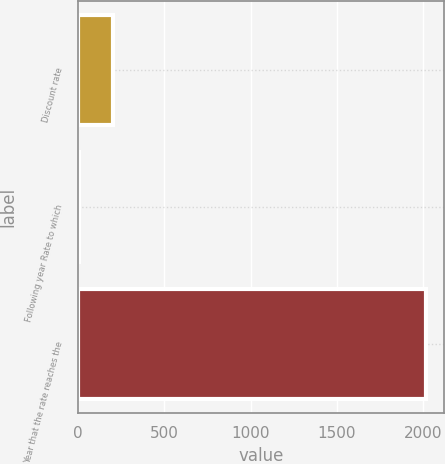Convert chart to OTSL. <chart><loc_0><loc_0><loc_500><loc_500><bar_chart><fcel>Discount rate<fcel>Following year Rate to which<fcel>Year that the rate reaches the<nl><fcel>206.3<fcel>5<fcel>2018<nl></chart> 